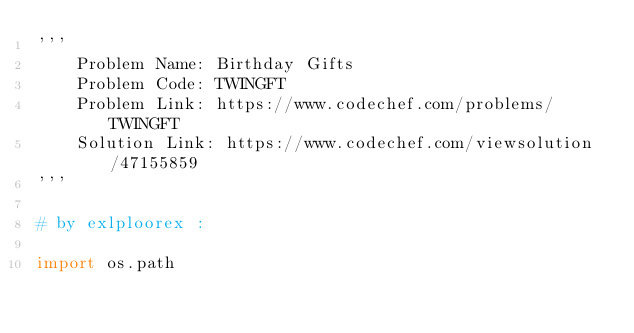Convert code to text. <code><loc_0><loc_0><loc_500><loc_500><_Python_>'''
    Problem Name: Birthday Gifts
    Problem Code: TWINGFT
    Problem Link: https://www.codechef.com/problems/TWINGFT
    Solution Link: https://www.codechef.com/viewsolution/47155859
'''

# by exlploorex :

import os.path</code> 